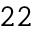<formula> <loc_0><loc_0><loc_500><loc_500>^ { 2 2 }</formula> 